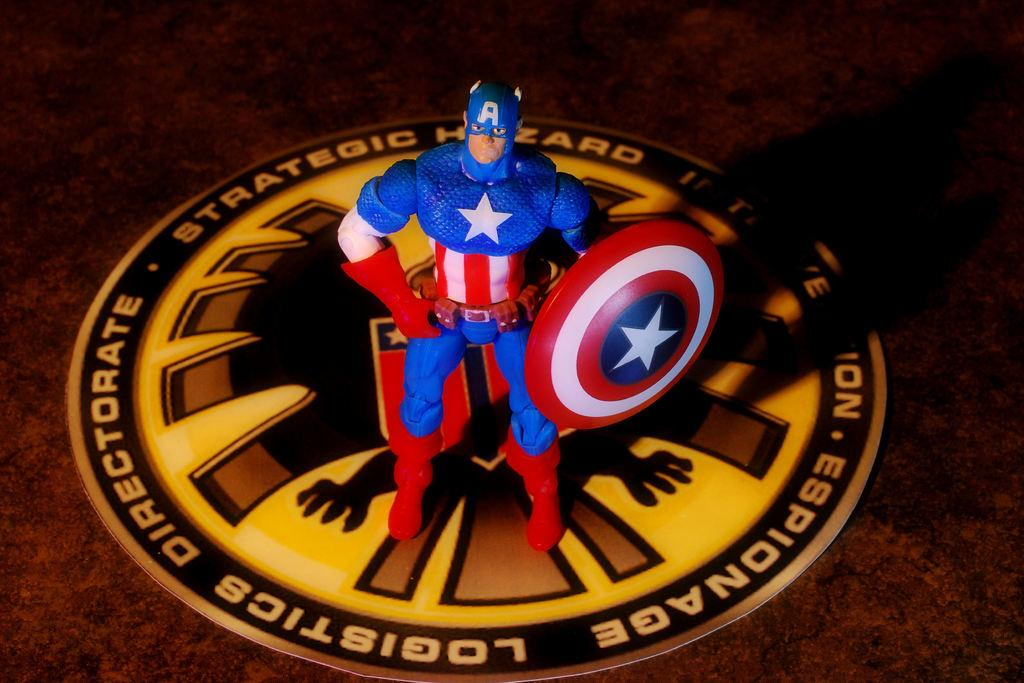What is the person (you) doing on the surface? The person (you) is on the surface, but the specific activity is not mentioned in the facts. What can be seen near the person (you) on the surface? There is a toy holding a shield and a poster on the surface. Can you see a tiger playing volleyball with the toy in the image? No, there is no tiger or volleyball present in the image. 